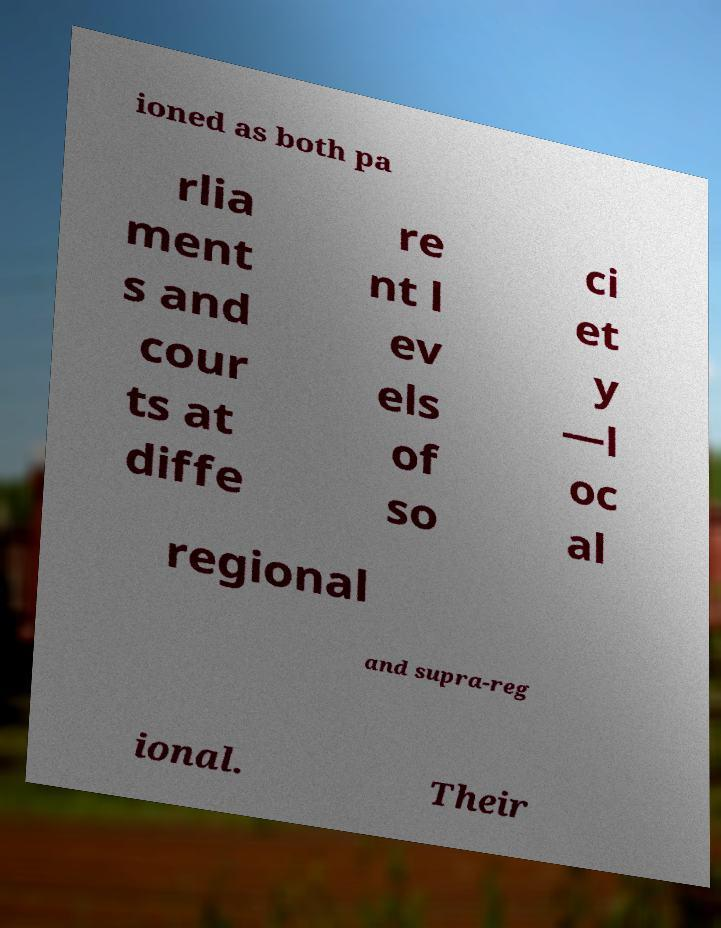Could you extract and type out the text from this image? ioned as both pa rlia ment s and cour ts at diffe re nt l ev els of so ci et y —l oc al regional and supra-reg ional. Their 